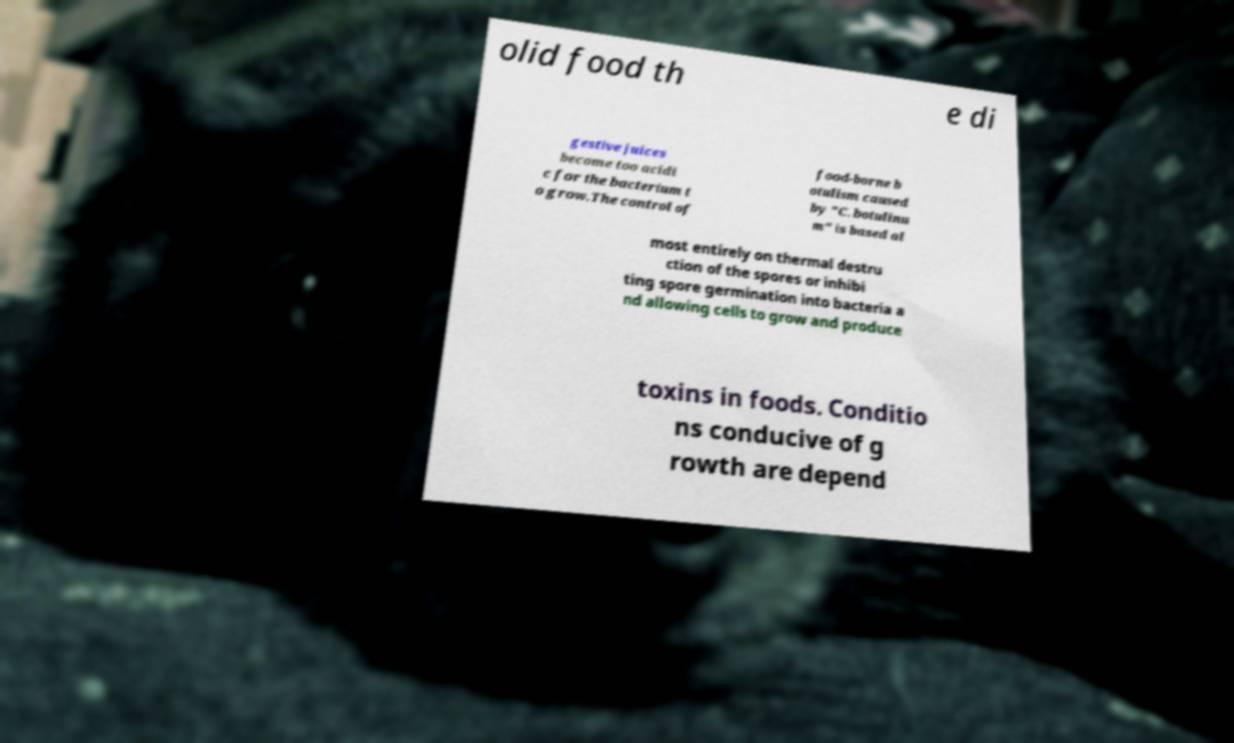There's text embedded in this image that I need extracted. Can you transcribe it verbatim? olid food th e di gestive juices become too acidi c for the bacterium t o grow.The control of food-borne b otulism caused by "C. botulinu m" is based al most entirely on thermal destru ction of the spores or inhibi ting spore germination into bacteria a nd allowing cells to grow and produce toxins in foods. Conditio ns conducive of g rowth are depend 